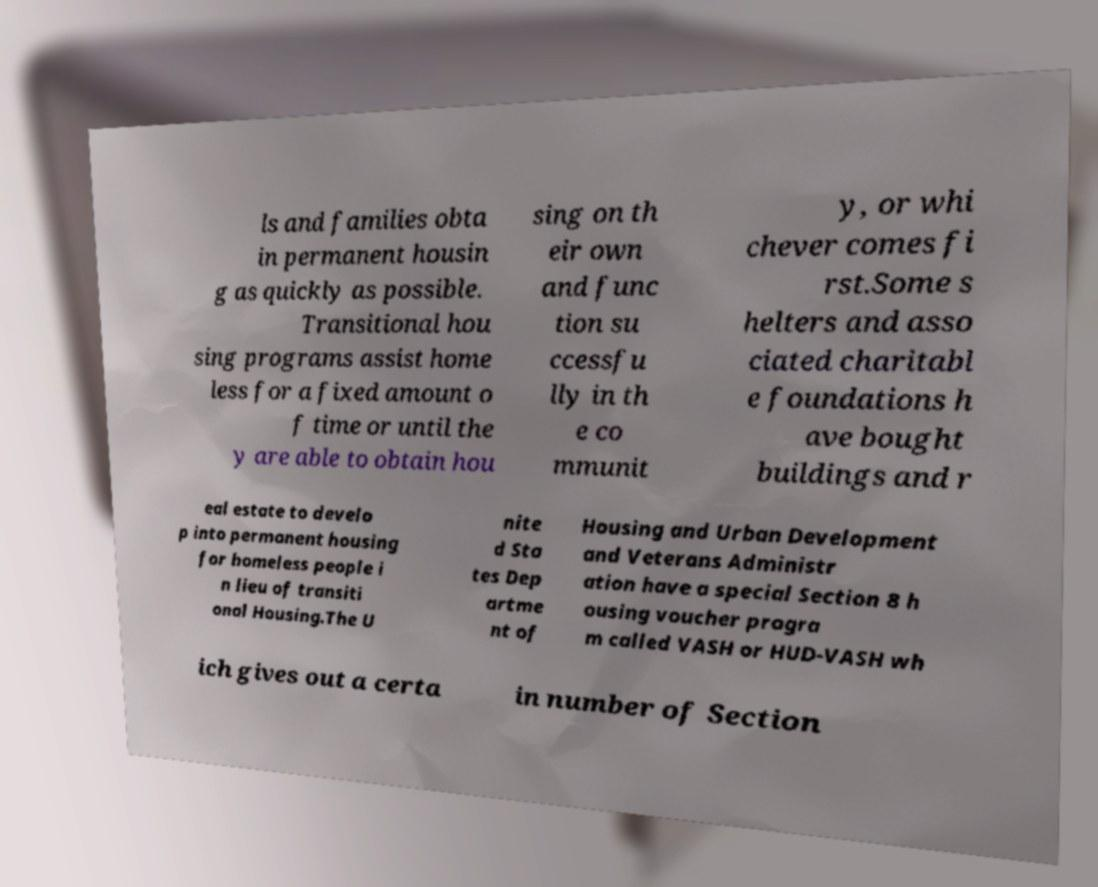For documentation purposes, I need the text within this image transcribed. Could you provide that? ls and families obta in permanent housin g as quickly as possible. Transitional hou sing programs assist home less for a fixed amount o f time or until the y are able to obtain hou sing on th eir own and func tion su ccessfu lly in th e co mmunit y, or whi chever comes fi rst.Some s helters and asso ciated charitabl e foundations h ave bought buildings and r eal estate to develo p into permanent housing for homeless people i n lieu of transiti onal Housing.The U nite d Sta tes Dep artme nt of Housing and Urban Development and Veterans Administr ation have a special Section 8 h ousing voucher progra m called VASH or HUD-VASH wh ich gives out a certa in number of Section 